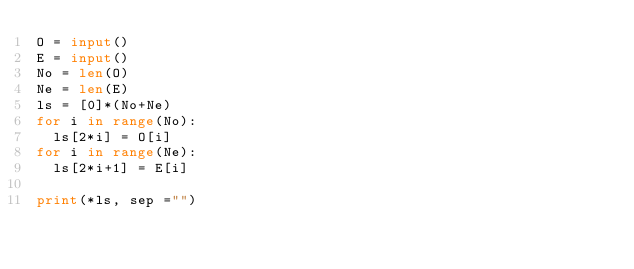<code> <loc_0><loc_0><loc_500><loc_500><_Python_>O = input()
E = input()
No = len(O)
Ne = len(E)
ls = [0]*(No+Ne)
for i in range(No):
  ls[2*i] = O[i]
for i in range(Ne):
  ls[2*i+1] = E[i]

print(*ls, sep ="")</code> 